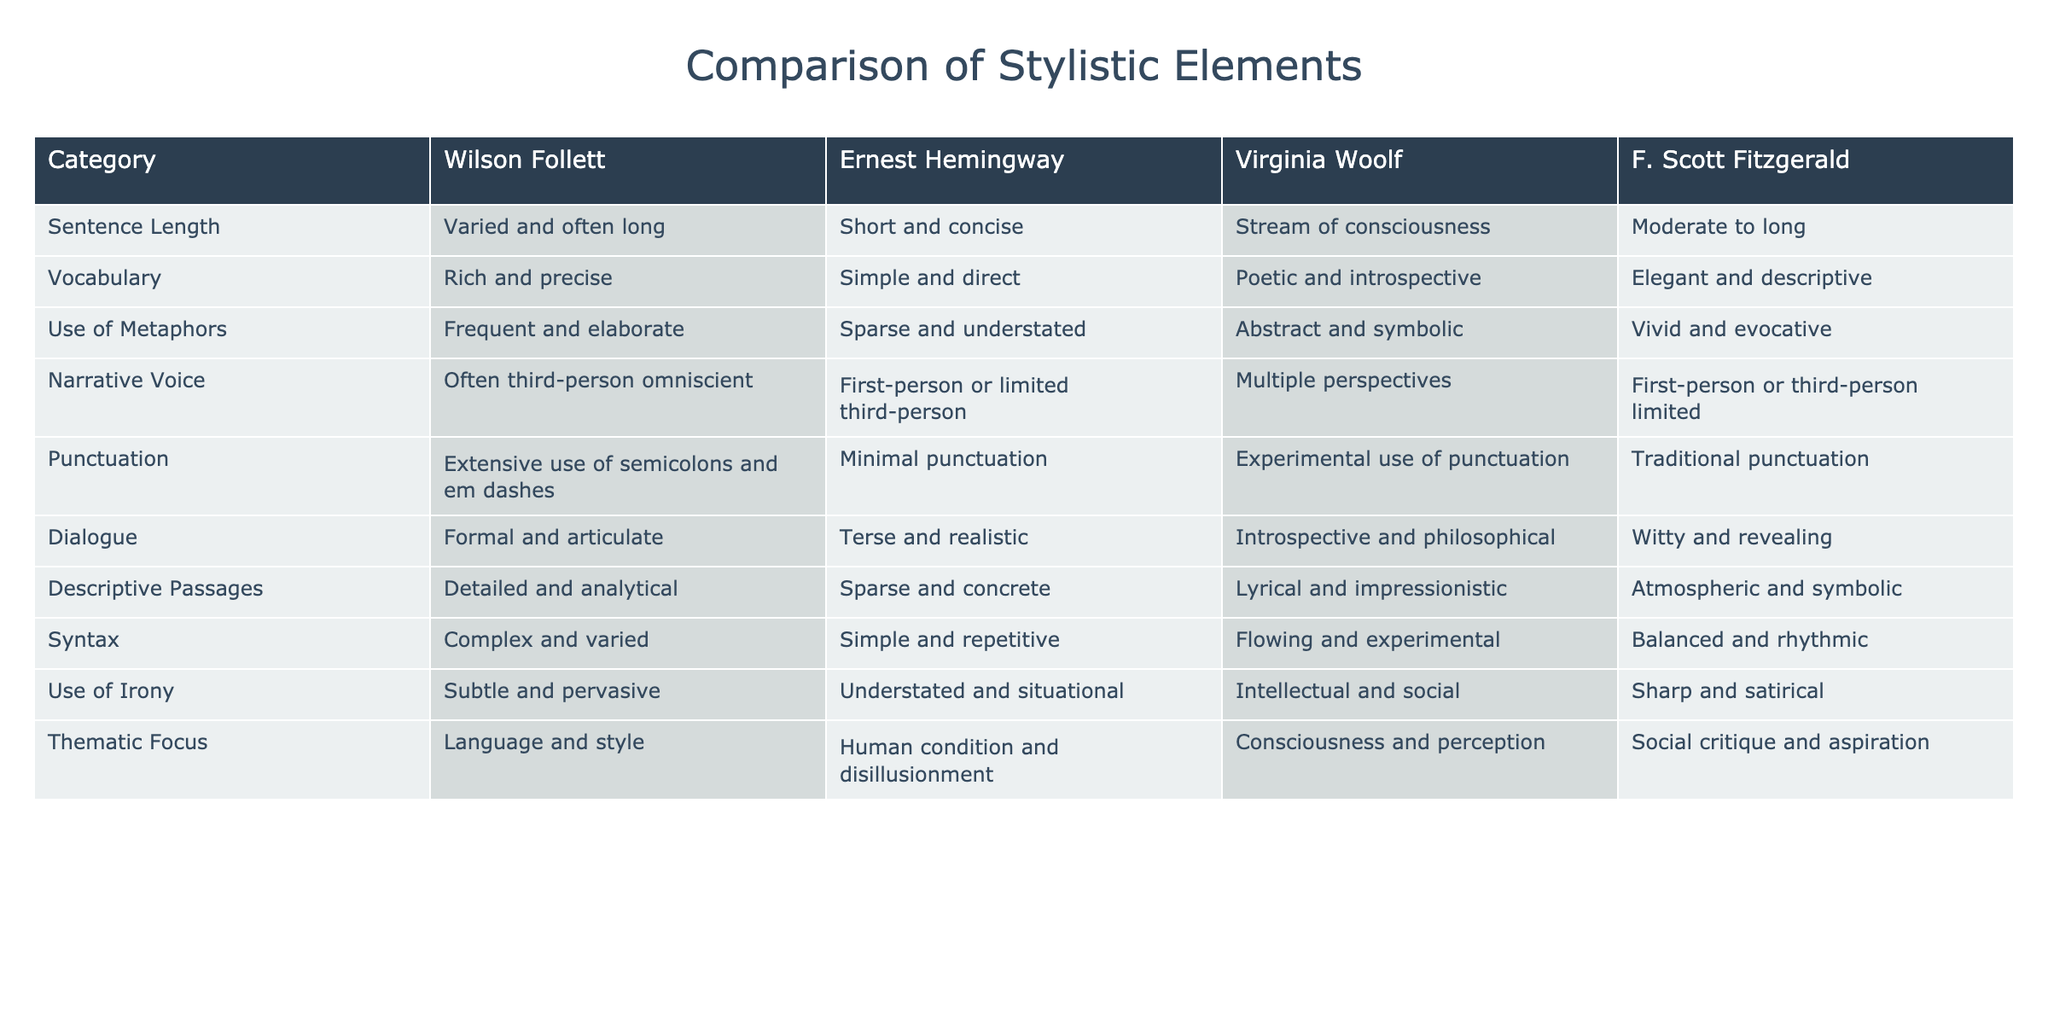What is the sentence length in Wilson Follett's writing? The sentence length for Wilson Follett is listed as "Varied and often long" in the table, which provides direct information from the relevant cell.
Answer: Varied and often long How does Virginia Woolf's vocabulary compare to Wilson Follett's? Virginia Woolf's vocabulary is described as "Poetic and introspective," while Wilson Follett's is "Rich and precise." The comparison shows that Follett's vocabulary is more focused on precision, while Woolf's leans towards poetry.
Answer: Wilson Follett's vocabulary is more precise Is F. Scott Fitzgerald's use of metaphors more vivid compared to Wilson Follett's? The table indicates that Fitzgerald uses "Vivid and evocative" metaphors, whereas Follett employs "Frequent and elaborate" metaphors. While both are rich, Fitzgerald's metaphors are specifically noted for their vividness, suggesting a difference in style rather than a direct comparison in intensity.
Answer: Yes, Fitzgerald's metaphors are more vivid Which author features the most complex syntax? Wilson Follett's syntax is described as "Complex and varied," contrasting with Hemingway's "Simple and repetitive" syntax and others that are more moderate. This shows that Follett stands out for complexity.
Answer: Wilson Follett Is there any author who uses traditional punctuation? F. Scott Fitzgerald is indicated as using "Traditional punctuation." Upon checking other author entries, Follett, Woolf, and Hemingway indicate different styles, confirming that Fitzgerald is the only one noted for traditional use.
Answer: Yes, F. Scott Fitzgerald uses traditional punctuation How does the thematic focus of contemporary authors, like Hemingway, differ from Wilson Follett's? Wilson Follett focuses on "Language and style," while Hemingway's thematic focus is described as "Human condition and disillusionment." This indicates a shift from Follett's stylistic exploration to a more existential exploration in Hemingway's work.
Answer: Thematic focuses differ significantly Which author is noted for having a formal dialogue style? The table shows that Wilson Follett's dialogue is described as "Formal and articulate." In contrast, the dialogue styles of the other authors are less formal, making Follett distinctive in this respect.
Answer: Wilson Follett is noted for formal dialogue What is the average length of sentence styles used by all authors listed? Based on the descriptions, Wilson Follett has varied and often long sentences, Hemingway is short and concise, Woolf uses stream of consciousness, and Fitzgerald's length is moderate to long. While exact sentence lengths aren't provided to compute an average, a qualitative summary may suggest that Follett's and Fitzgerald's forms lean towards longer styles, whereas Hemingway favors brevity. It appears that no strict calculation could be made but an approximation leans towards longer sentence forms overall.
Answer: Cannot determine precise average 